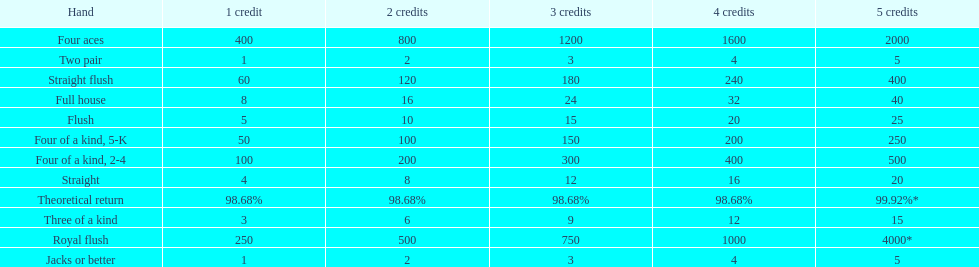Is a 2 credit full house the same as a 5 credit three of a kind? No. 